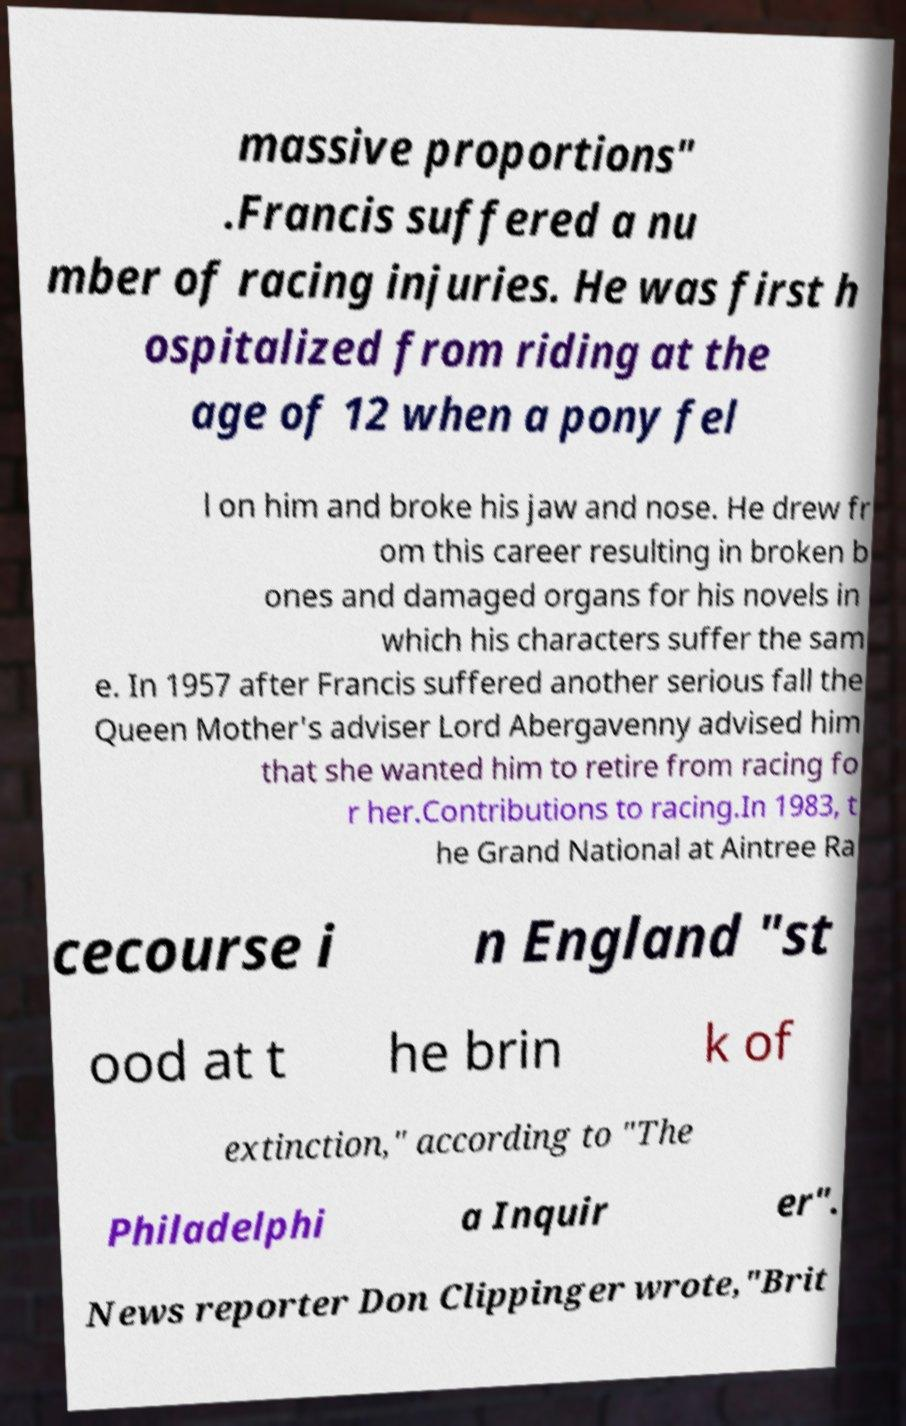For documentation purposes, I need the text within this image transcribed. Could you provide that? massive proportions" .Francis suffered a nu mber of racing injuries. He was first h ospitalized from riding at the age of 12 when a pony fel l on him and broke his jaw and nose. He drew fr om this career resulting in broken b ones and damaged organs for his novels in which his characters suffer the sam e. In 1957 after Francis suffered another serious fall the Queen Mother's adviser Lord Abergavenny advised him that she wanted him to retire from racing fo r her.Contributions to racing.In 1983, t he Grand National at Aintree Ra cecourse i n England "st ood at t he brin k of extinction," according to "The Philadelphi a Inquir er". News reporter Don Clippinger wrote,"Brit 